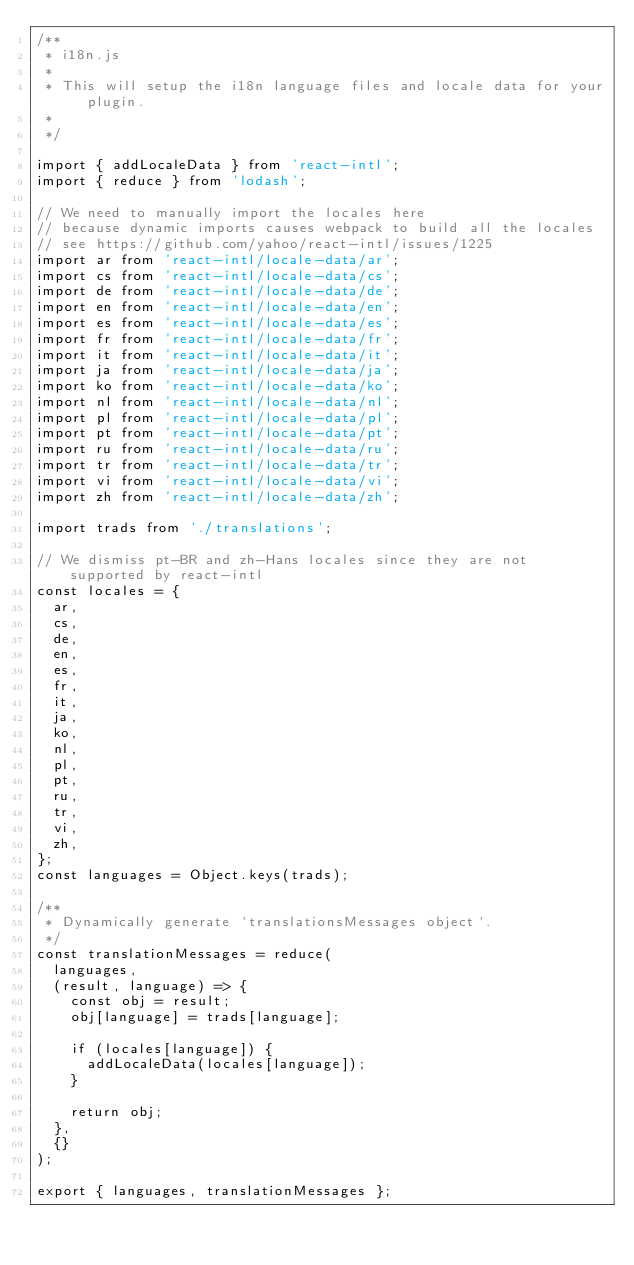Convert code to text. <code><loc_0><loc_0><loc_500><loc_500><_JavaScript_>/**
 * i18n.js
 *
 * This will setup the i18n language files and locale data for your plugin.
 *
 */

import { addLocaleData } from 'react-intl';
import { reduce } from 'lodash';

// We need to manually import the locales here
// because dynamic imports causes webpack to build all the locales
// see https://github.com/yahoo/react-intl/issues/1225
import ar from 'react-intl/locale-data/ar';
import cs from 'react-intl/locale-data/cs';
import de from 'react-intl/locale-data/de';
import en from 'react-intl/locale-data/en';
import es from 'react-intl/locale-data/es';
import fr from 'react-intl/locale-data/fr';
import it from 'react-intl/locale-data/it';
import ja from 'react-intl/locale-data/ja';
import ko from 'react-intl/locale-data/ko';
import nl from 'react-intl/locale-data/nl';
import pl from 'react-intl/locale-data/pl';
import pt from 'react-intl/locale-data/pt';
import ru from 'react-intl/locale-data/ru';
import tr from 'react-intl/locale-data/tr';
import vi from 'react-intl/locale-data/vi';
import zh from 'react-intl/locale-data/zh';

import trads from './translations';

// We dismiss pt-BR and zh-Hans locales since they are not supported by react-intl
const locales = {
  ar,
  cs,
  de,
  en,
  es,
  fr,
  it,
  ja,
  ko,
  nl,
  pl,
  pt,
  ru,
  tr,
  vi,
  zh,
};
const languages = Object.keys(trads);

/**
 * Dynamically generate `translationsMessages object`.
 */
const translationMessages = reduce(
  languages,
  (result, language) => {
    const obj = result;
    obj[language] = trads[language];

    if (locales[language]) {
      addLocaleData(locales[language]);
    }

    return obj;
  },
  {}
);

export { languages, translationMessages };
</code> 